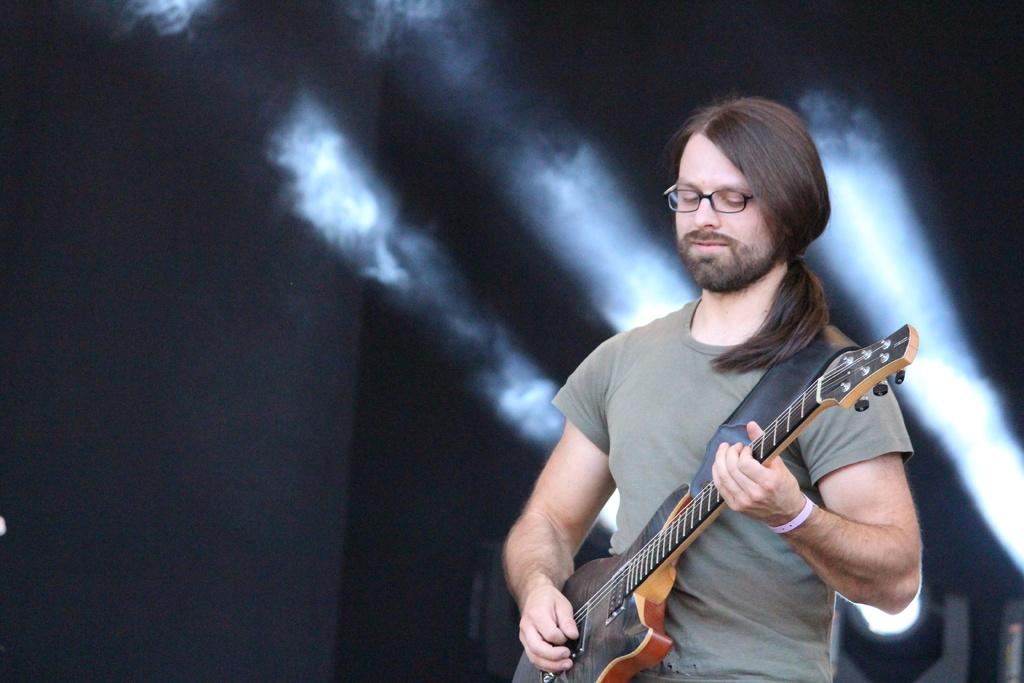What is the person in the image doing? The person is standing in the image and holding a guitar. What object is the person holding in the image? The person is holding a guitar. What can be seen in the background of the image? There are focusing lights in the background of the image. What type of bottle is visible in the image? There is no bottle present in the image. What type of clouds can be seen in the image? There are no clouds visible in the image. 